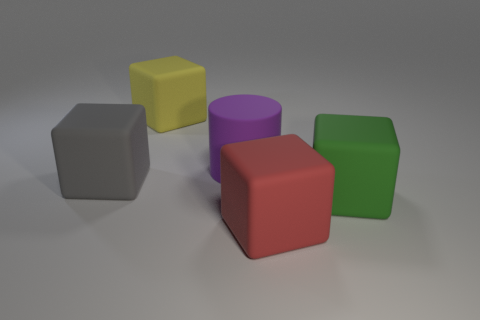Add 1 big red objects. How many objects exist? 6 Subtract all cylinders. How many objects are left? 4 Subtract all big purple rubber cylinders. Subtract all gray objects. How many objects are left? 3 Add 5 gray blocks. How many gray blocks are left? 6 Add 5 small blue shiny balls. How many small blue shiny balls exist? 5 Subtract 1 green cubes. How many objects are left? 4 